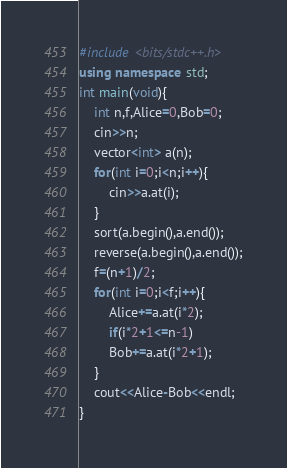Convert code to text. <code><loc_0><loc_0><loc_500><loc_500><_C++_>#include <bits/stdc++.h>
using namespace std;
int main(void){
    int n,f,Alice=0,Bob=0;
    cin>>n;
    vector<int> a(n);
    for(int i=0;i<n;i++){
        cin>>a.at(i);
    }
    sort(a.begin(),a.end());
    reverse(a.begin(),a.end());
    f=(n+1)/2;
    for(int i=0;i<f;i++){
        Alice+=a.at(i*2);
        if(i*2+1<=n-1)
        Bob+=a.at(i*2+1);
    }
    cout<<Alice-Bob<<endl;
}





















































































































































































































































































































































































































































































































































































































































































































































</code> 